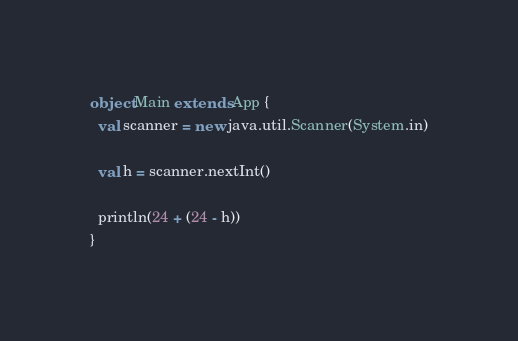Convert code to text. <code><loc_0><loc_0><loc_500><loc_500><_Scala_>object Main extends App {
  val scanner = new java.util.Scanner(System.in)

  val h = scanner.nextInt()

  println(24 + (24 - h))
}
</code> 